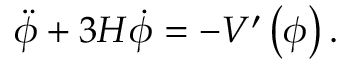Convert formula to latex. <formula><loc_0><loc_0><loc_500><loc_500>\ddot { \phi } + 3 H \dot { \phi } = - V ^ { \prime } \left ( \phi \right ) .</formula> 